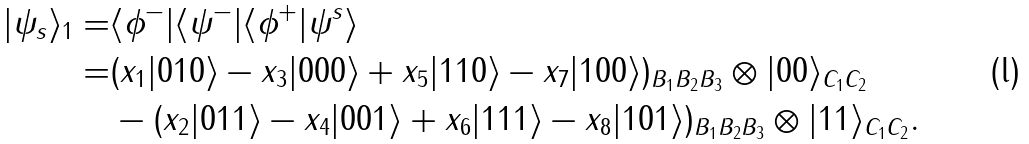<formula> <loc_0><loc_0><loc_500><loc_500>| \psi _ { s } \rangle _ { 1 } = & \langle \phi ^ { - } | \langle \psi ^ { - } | \langle \phi ^ { + } | \psi ^ { s } \rangle \\ = & ( x _ { 1 } | 0 1 0 \rangle - x _ { 3 } | 0 0 0 \rangle + x _ { 5 } | 1 1 0 \rangle - x _ { 7 } | 1 0 0 \rangle ) _ { B _ { 1 } B _ { 2 } B _ { 3 } } \otimes | 0 0 \rangle _ { C _ { 1 } C _ { 2 } } \\ & - ( x _ { 2 } | 0 1 1 \rangle - x _ { 4 } | 0 0 1 \rangle + x _ { 6 } | 1 1 1 \rangle - x _ { 8 } | 1 0 1 \rangle ) _ { B _ { 1 } B _ { 2 } B _ { 3 } } \otimes | 1 1 \rangle _ { C _ { 1 } C _ { 2 } } .</formula> 